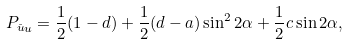Convert formula to latex. <formula><loc_0><loc_0><loc_500><loc_500>P _ { \stackrel { \_ } { u } u } = \frac { 1 } { 2 } ( 1 - d ) + \frac { 1 } { 2 } ( d - a ) \sin ^ { 2 } 2 \alpha + \frac { 1 } { 2 } c \sin 2 \alpha ,</formula> 